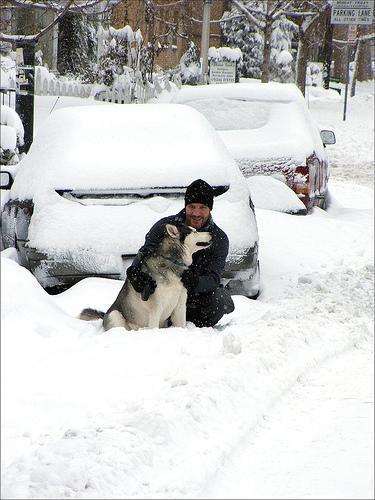How many vehicles are shown?
Give a very brief answer. 2. 